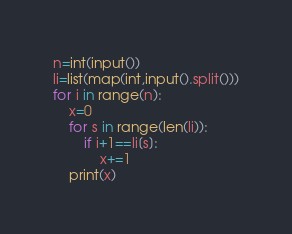Convert code to text. <code><loc_0><loc_0><loc_500><loc_500><_Python_>n=int(input())
li=list(map(int,input().split()))
for i in range(n):
    x=0
    for s in range(len(li)):
        if i+1==li[s]:
            x+=1
    print(x)</code> 